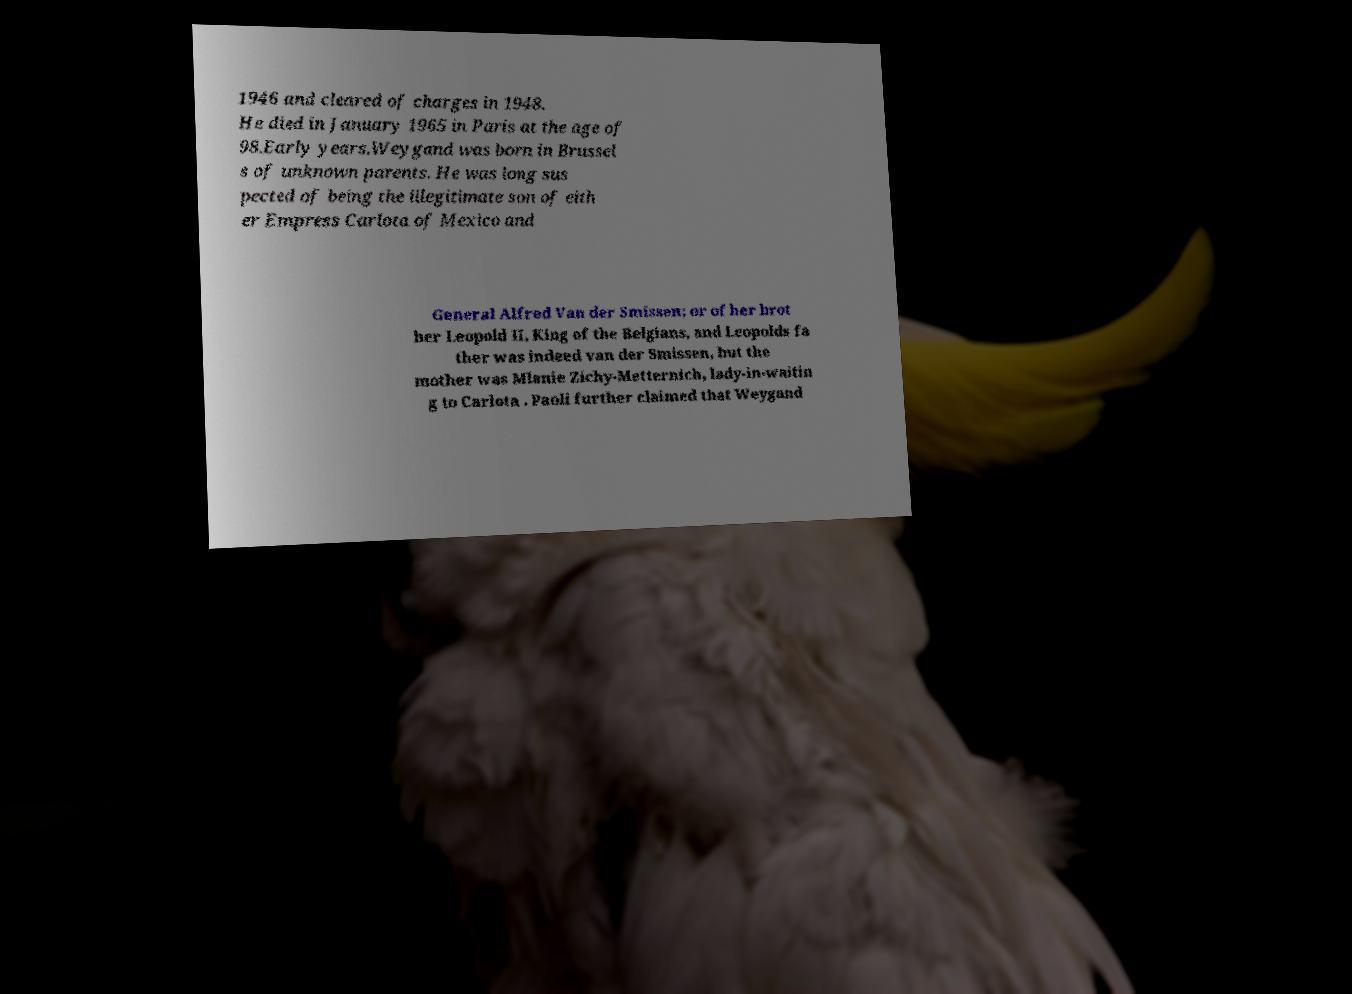Could you extract and type out the text from this image? 1946 and cleared of charges in 1948. He died in January 1965 in Paris at the age of 98.Early years.Weygand was born in Brussel s of unknown parents. He was long sus pected of being the illegitimate son of eith er Empress Carlota of Mexico and General Alfred Van der Smissen; or of her brot her Leopold II, King of the Belgians, and Leopolds fa ther was indeed van der Smissen, but the mother was Mlanie Zichy-Metternich, lady-in-waitin g to Carlota . Paoli further claimed that Weygand 